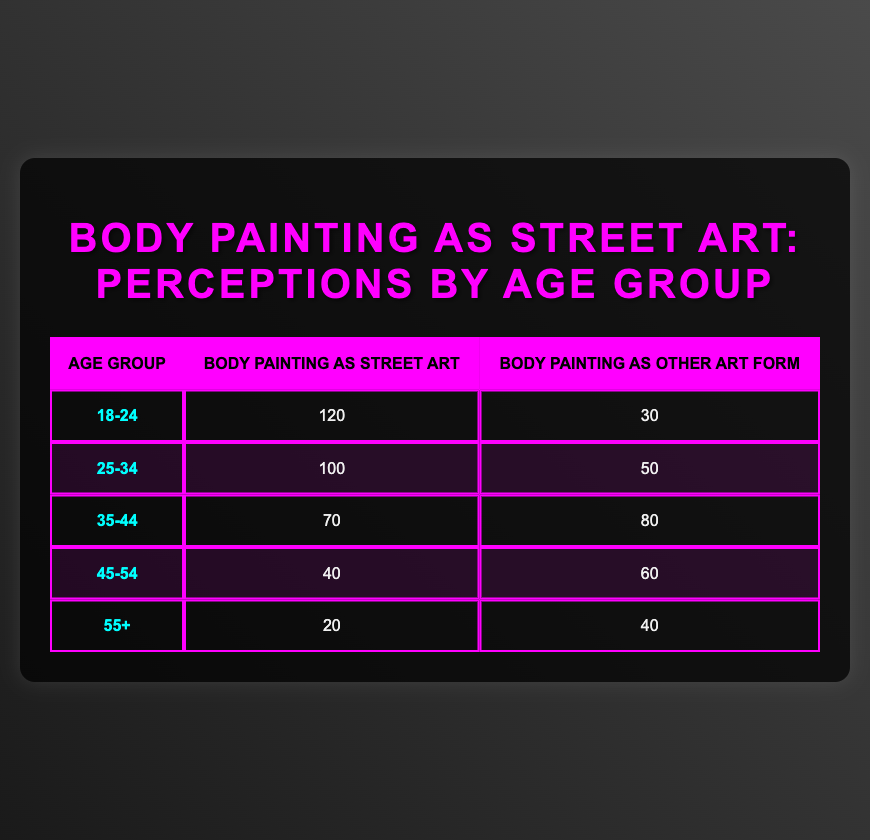What is the count of people aged 18-24 who perceive body painting as street art? From the table, the count of people aged 18-24 who see body painting as street art is listed directly under that age group in the relevant column, which is 120.
Answer: 120 What is the total count of people who perceive body painting as other art forms across all age groups? To find this, I sum the counts in the "Body Painting as Other Art Form" column: 30 + 50 + 80 + 60 + 40 = 260.
Answer: 260 Is the perception of body painting as street art more prevalent among the 35-44 age group than the 45-54 age group? For the 35-44 age group, the count is 70 for street art, while for the 45-54 age group, it is 40. Since 70 is greater than 40, the answer is yes.
Answer: Yes What is the difference between the counts of people aged 25-34 who view body painting as street art and those who view it as other art forms? The count for the 25-34 age group perceiving it as street art is 100, and for other art forms, it is 50. The difference is 100 - 50 = 50.
Answer: 50 What age group has the highest count of individuals perceiving body painting as street art? By comparing the counts in the "Body Painting as Street Art" column: 120 (18-24), 100 (25-34), 70 (35-44), 40 (45-54), and 20 (55+), the highest is 120 for the 18-24 age group.
Answer: 18-24 What is the average count of people across all age groups perceiving body painting as street art? The total count for street art is 120 + 100 + 70 + 40 + 20 = 350. There are 5 age groups, so the average is 350 ÷ 5 = 70.
Answer: 70 